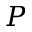<formula> <loc_0><loc_0><loc_500><loc_500>P</formula> 